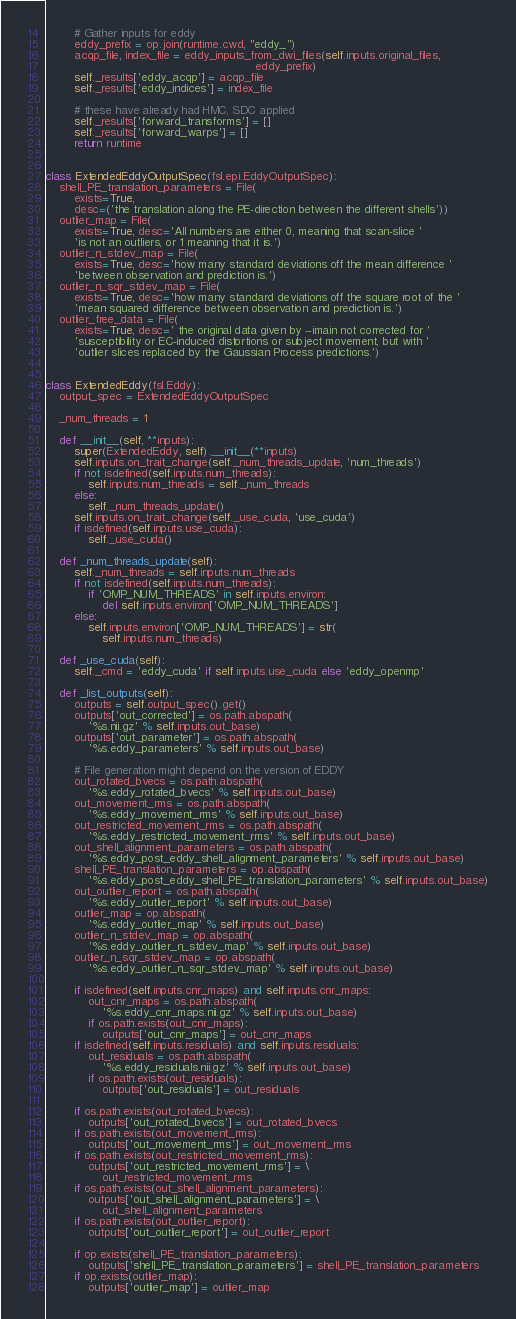Convert code to text. <code><loc_0><loc_0><loc_500><loc_500><_Python_>
        # Gather inputs for eddy
        eddy_prefix = op.join(runtime.cwd, "eddy_")
        acqp_file, index_file = eddy_inputs_from_dwi_files(self.inputs.original_files,
                                                           eddy_prefix)
        self._results['eddy_acqp'] = acqp_file
        self._results['eddy_indices'] = index_file

        # these have already had HMC, SDC applied
        self._results['forward_transforms'] = []
        self._results['forward_warps'] = []
        return runtime


class ExtendedEddyOutputSpec(fsl.epi.EddyOutputSpec):
    shell_PE_translation_parameters = File(
        exists=True,
        desc=('the translation along the PE-direction between the different shells'))
    outlier_map = File(
        exists=True, desc='All numbers are either 0, meaning that scan-slice '
        'is not an outliers, or 1 meaning that it is.')
    outlier_n_stdev_map = File(
        exists=True, desc='how many standard deviations off the mean difference '
        'between observation and prediction is.')
    outlier_n_sqr_stdev_map = File(
        exists=True, desc='how many standard deviations off the square root of the '
        'mean squared difference between observation and prediction is.')
    outlier_free_data = File(
        exists=True, desc=' the original data given by --imain not corrected for '
        'susceptibility or EC-induced distortions or subject movement, but with '
        'outlier slices replaced by the Gaussian Process predictions.')


class ExtendedEddy(fsl.Eddy):
    output_spec = ExtendedEddyOutputSpec

    _num_threads = 1

    def __init__(self, **inputs):
        super(ExtendedEddy, self).__init__(**inputs)
        self.inputs.on_trait_change(self._num_threads_update, 'num_threads')
        if not isdefined(self.inputs.num_threads):
            self.inputs.num_threads = self._num_threads
        else:
            self._num_threads_update()
        self.inputs.on_trait_change(self._use_cuda, 'use_cuda')
        if isdefined(self.inputs.use_cuda):
            self._use_cuda()

    def _num_threads_update(self):
        self._num_threads = self.inputs.num_threads
        if not isdefined(self.inputs.num_threads):
            if 'OMP_NUM_THREADS' in self.inputs.environ:
                del self.inputs.environ['OMP_NUM_THREADS']
        else:
            self.inputs.environ['OMP_NUM_THREADS'] = str(
                self.inputs.num_threads)

    def _use_cuda(self):
        self._cmd = 'eddy_cuda' if self.inputs.use_cuda else 'eddy_openmp'

    def _list_outputs(self):
        outputs = self.output_spec().get()
        outputs['out_corrected'] = os.path.abspath(
            '%s.nii.gz' % self.inputs.out_base)
        outputs['out_parameter'] = os.path.abspath(
            '%s.eddy_parameters' % self.inputs.out_base)

        # File generation might depend on the version of EDDY
        out_rotated_bvecs = os.path.abspath(
            '%s.eddy_rotated_bvecs' % self.inputs.out_base)
        out_movement_rms = os.path.abspath(
            '%s.eddy_movement_rms' % self.inputs.out_base)
        out_restricted_movement_rms = os.path.abspath(
            '%s.eddy_restricted_movement_rms' % self.inputs.out_base)
        out_shell_alignment_parameters = os.path.abspath(
            '%s.eddy_post_eddy_shell_alignment_parameters' % self.inputs.out_base)
        shell_PE_translation_parameters = op.abspath(
            '%s.eddy_post_eddy_shell_PE_translation_parameters' % self.inputs.out_base)
        out_outlier_report = os.path.abspath(
            '%s.eddy_outlier_report' % self.inputs.out_base)
        outlier_map = op.abspath(
            '%s.eddy_outlier_map' % self.inputs.out_base)
        outlier_n_stdev_map = op.abspath(
            '%s.eddy_outlier_n_stdev_map' % self.inputs.out_base)
        outlier_n_sqr_stdev_map = op.abspath(
            '%s.eddy_outlier_n_sqr_stdev_map' % self.inputs.out_base)

        if isdefined(self.inputs.cnr_maps) and self.inputs.cnr_maps:
            out_cnr_maps = os.path.abspath(
                '%s.eddy_cnr_maps.nii.gz' % self.inputs.out_base)
            if os.path.exists(out_cnr_maps):
                outputs['out_cnr_maps'] = out_cnr_maps
        if isdefined(self.inputs.residuals) and self.inputs.residuals:
            out_residuals = os.path.abspath(
                '%s.eddy_residuals.nii.gz' % self.inputs.out_base)
            if os.path.exists(out_residuals):
                outputs['out_residuals'] = out_residuals

        if os.path.exists(out_rotated_bvecs):
            outputs['out_rotated_bvecs'] = out_rotated_bvecs
        if os.path.exists(out_movement_rms):
            outputs['out_movement_rms'] = out_movement_rms
        if os.path.exists(out_restricted_movement_rms):
            outputs['out_restricted_movement_rms'] = \
                out_restricted_movement_rms
        if os.path.exists(out_shell_alignment_parameters):
            outputs['out_shell_alignment_parameters'] = \
                out_shell_alignment_parameters
        if os.path.exists(out_outlier_report):
            outputs['out_outlier_report'] = out_outlier_report

        if op.exists(shell_PE_translation_parameters):
            outputs['shell_PE_translation_parameters'] = shell_PE_translation_parameters
        if op.exists(outlier_map):
            outputs['outlier_map'] = outlier_map</code> 